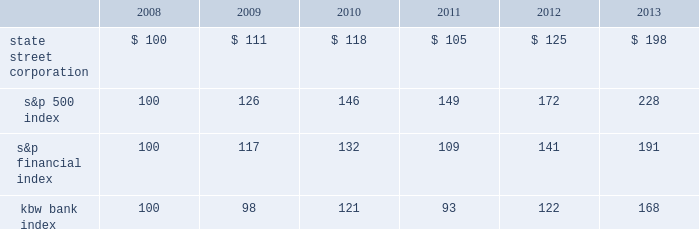Shareholder return performance presentation the graph presented below compares the cumulative total shareholder return on state street's common stock to the cumulative total return of the s&p 500 index , the s&p financial index and the kbw bank index over a five- year period .
The cumulative total shareholder return assumes the investment of $ 100 in state street common stock and in each index on december 31 , 2008 at the closing price on the last trading day of 2008 , and also assumes reinvestment of common stock dividends .
The s&p financial index is a publicly available measure of 81 of the standard & poor's 500 companies , representing 17 diversified financial services companies , 22 insurance companies , 19 real estate companies and 23 banking companies .
The kbw bank index seeks to reflect the performance of banks and thrifts that are publicly traded in the u.s. , and is composed of 24 leading national money center and regional banks and thrifts. .

How much higher are the returns of the s&p 500 in the same period ( 2008-2013 ) ? as a percentage .? 
Rationale: used result from question 1
Computations: ((228 / 100) / 100)
Answer: 0.0228. 